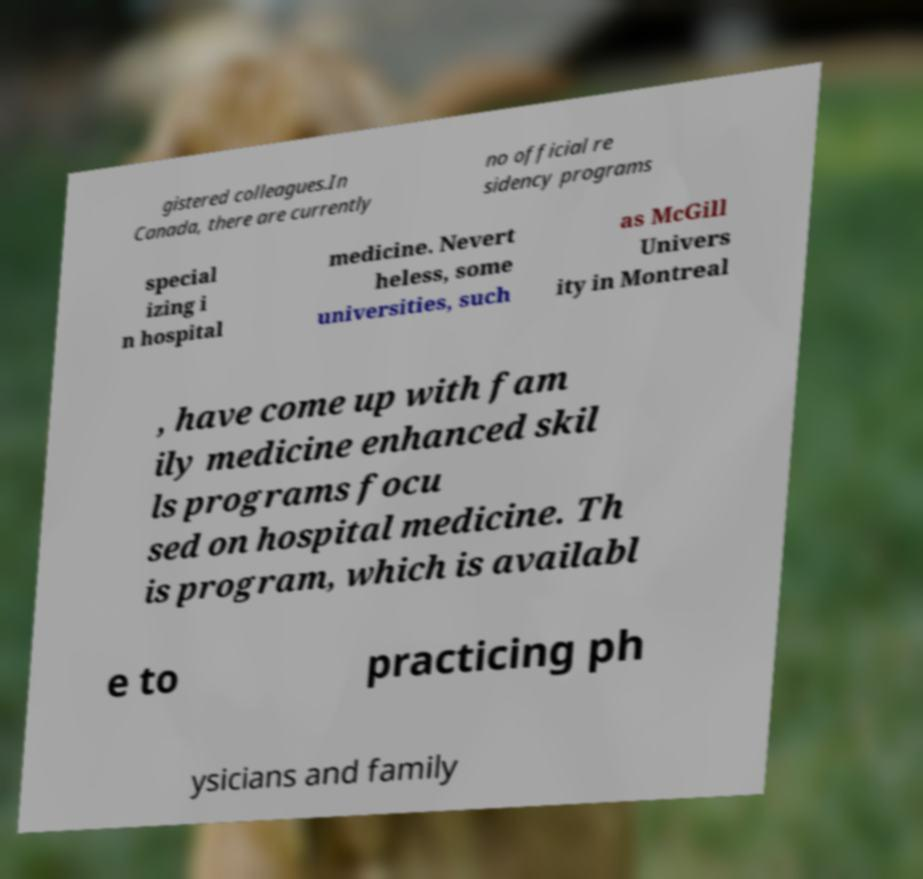Can you accurately transcribe the text from the provided image for me? gistered colleagues.In Canada, there are currently no official re sidency programs special izing i n hospital medicine. Nevert heless, some universities, such as McGill Univers ity in Montreal , have come up with fam ily medicine enhanced skil ls programs focu sed on hospital medicine. Th is program, which is availabl e to practicing ph ysicians and family 